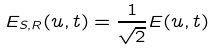<formula> <loc_0><loc_0><loc_500><loc_500>E _ { S , R } ( u , t ) = \frac { 1 } { \sqrt { 2 } } E ( u , t )</formula> 